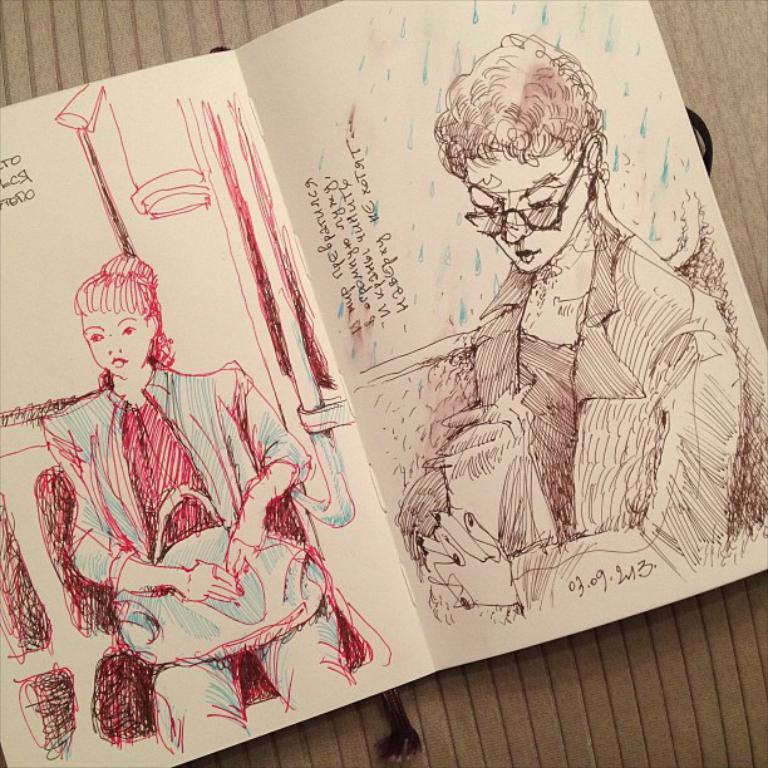What is the main object in the image? There is a card in the image. What can be found on the card? The card has text and a drawing on it. What type of beast is depicted on the calculator in the image? There is no calculator present in the image, and therefore no beast can be observed on it. 